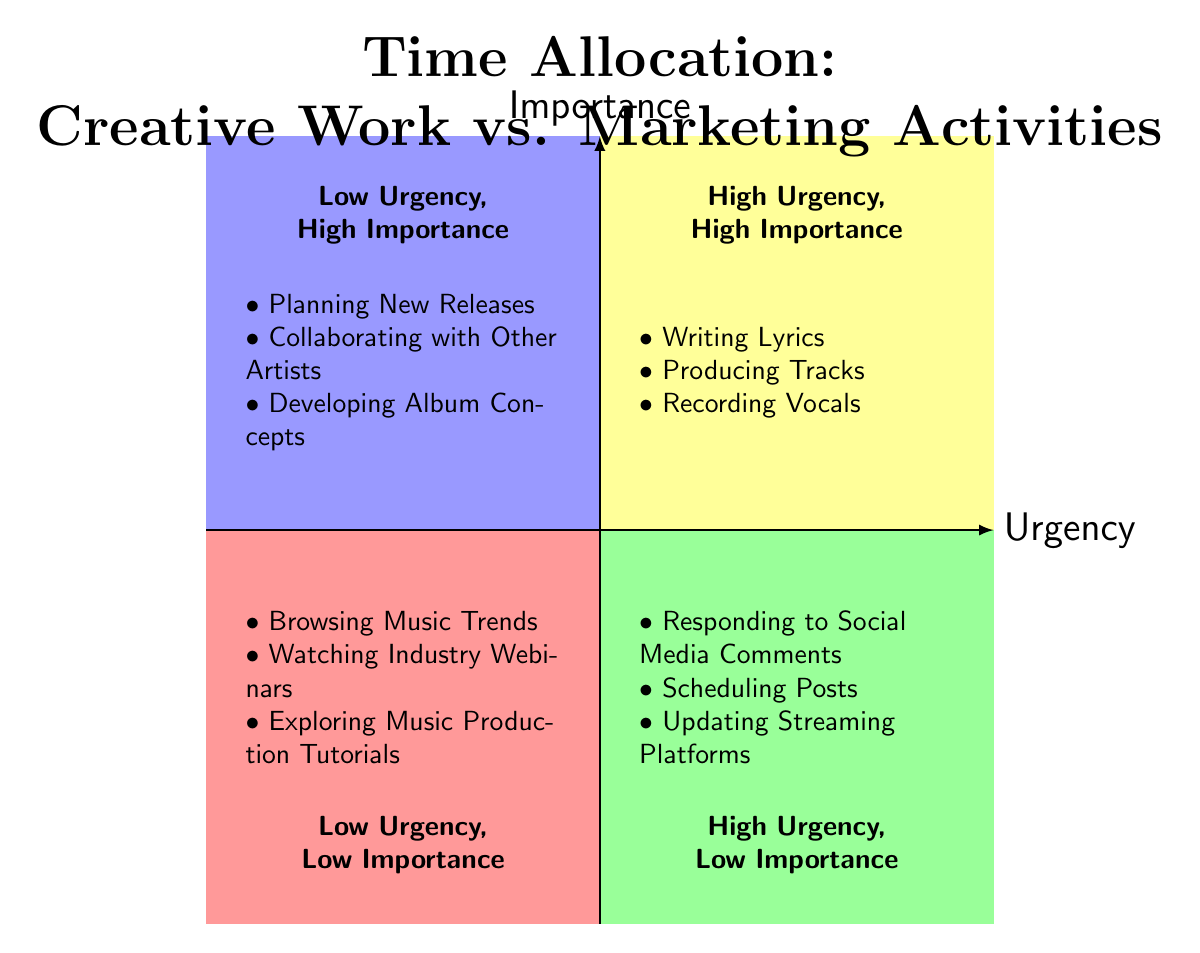What are the elements in the "High Urgency, High Importance" quadrant? The "High Urgency, High Importance" quadrant contains three elements: Writing Lyrics, Producing Tracks, and Recording Vocals. These are directly listed in that quadrant of the diagram.
Answer: Writing Lyrics, Producing Tracks, Recording Vocals How many elements are listed in the "Low Urgency, Low Importance" quadrant? The "Low Urgency, Low Importance" quadrant lists three elements: Browsing Music Trends, Watching Industry Webinars, and Exploring Music Production Tutorials. The total number of elements can be counted directly from the quadrant.
Answer: 3 Which activities are characterized as "High Urgency, Low Importance"? The "High Urgency, Low Importance" quadrant contains the following activities: Responding to Social Media Comments, Scheduling Posts, and Updating Streaming Platforms. These activities can be seen in that specific quadrant.
Answer: Responding to Social Media Comments, Scheduling Posts, Updating Streaming Platforms In terms of urgency and importance, what is the common theme of the elements in the "Low Urgency, High Importance" quadrant? The "Low Urgency, High Importance" quadrant focuses on long-term planning and collaboration within the music industry. Activities like Planning New Releases, Collaborating with Other Artists, and Developing Album Concepts emphasize strategic importance despite being less urgent. This can be deduced from the nature of the listed elements in that quadrant.
Answer: Long-term planning and collaboration What is the primary focus of activities in the "Low Urgency, Low Importance" quadrant? The activities in the "Low Urgency, Low Importance" quadrant generally focus on exploration and research related to the music industry, such as Browsing Music Trends and Watching Industry Webinars. These elements are less critical and do not require immediate attention, reflecting an exploratory mindset.
Answer: Exploration and research 